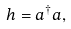Convert formula to latex. <formula><loc_0><loc_0><loc_500><loc_500>h = a ^ { \dagger } a ,</formula> 